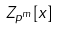<formula> <loc_0><loc_0><loc_500><loc_500>Z _ { p ^ { m } } [ x ]</formula> 